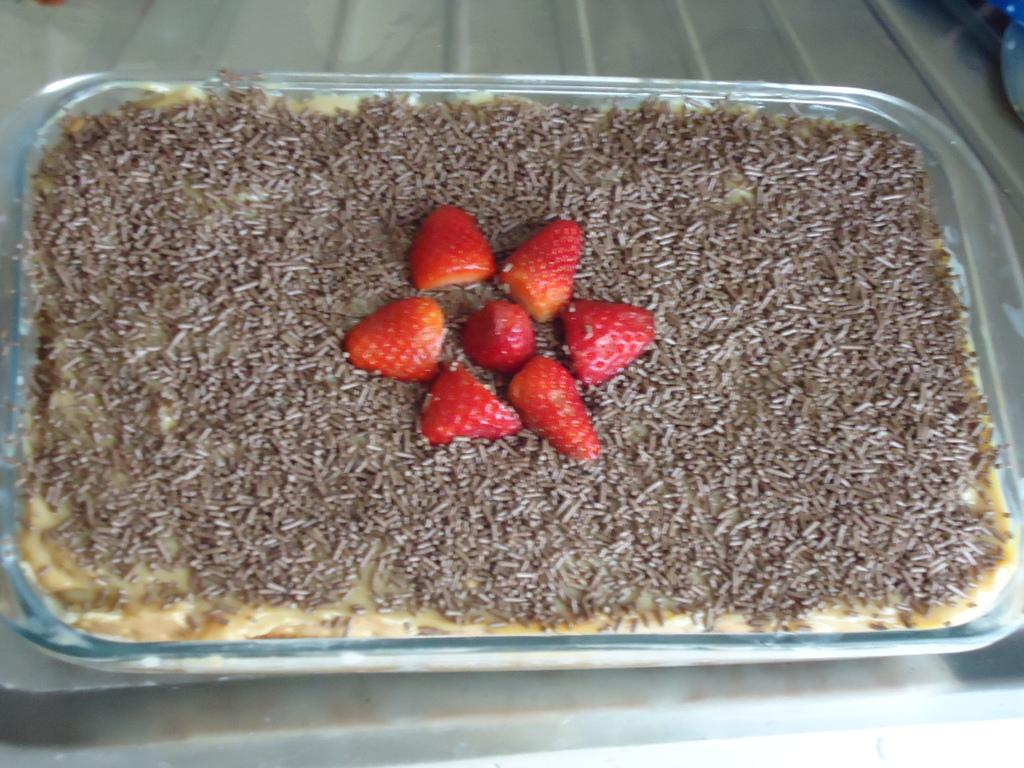What is on the table in the image? There is a bowl on the table in the image. What is inside the bowl? There are food items in the bowl. Are there any flowers growing out of the food items in the bowl? No, there are no flowers growing out of the food items in the bowl. 